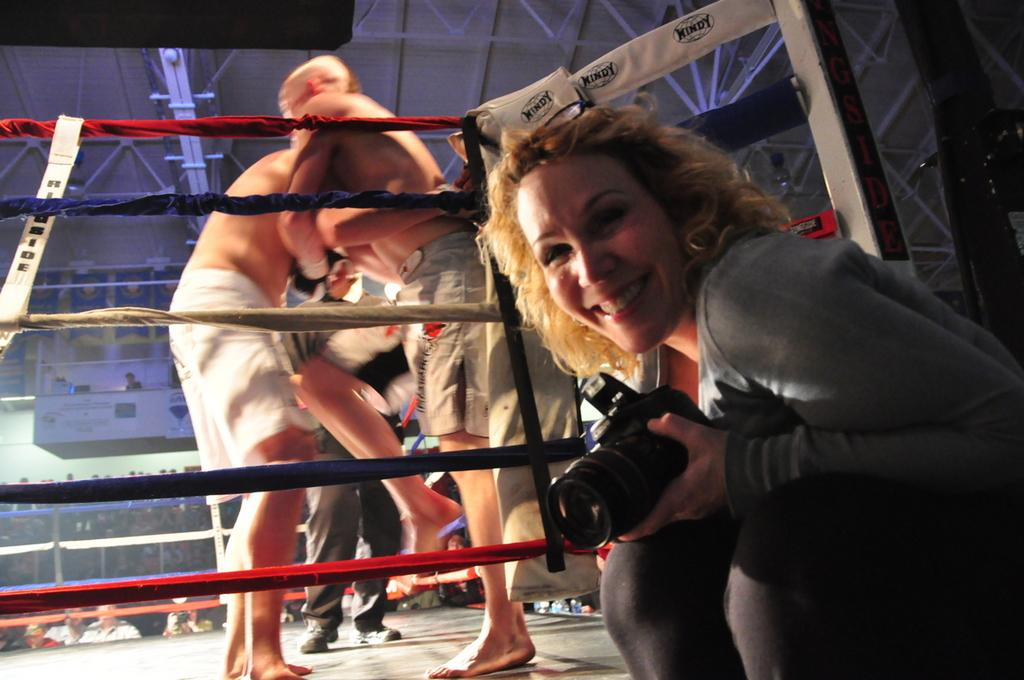Where is the location of the image? The image is inside a stadium. What is the woman at the front of the image doing? The woman is sitting and smiling in the image. What is the woman holding? The woman is holding a camera. Can you describe the actions of the two persons at the back of the image? The two persons at the back of the image appear to be fighting. What type of grape is being used as a prop in the image? There is no grape present in the image. How many spiders are crawling on the woman's camera in the image? There are no spiders visible in the image, and the woman is holding a camera. 